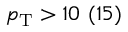<formula> <loc_0><loc_0><loc_500><loc_500>p _ { T } > 1 0 \ ( 1 5 )</formula> 